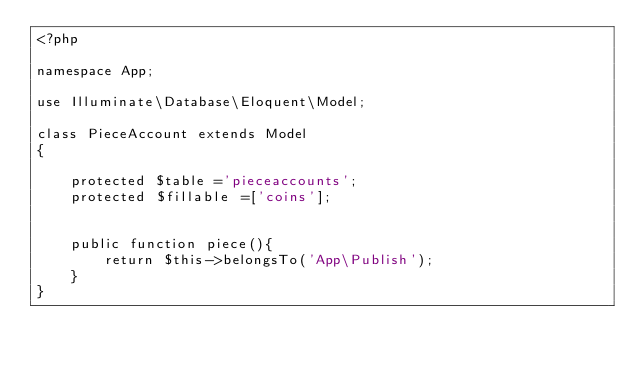<code> <loc_0><loc_0><loc_500><loc_500><_PHP_><?php

namespace App;

use Illuminate\Database\Eloquent\Model;

class PieceAccount extends Model
{

    protected $table ='pieceaccounts';
    protected $fillable =['coins'];


    public function piece(){
        return $this->belongsTo('App\Publish');
    }
}
</code> 